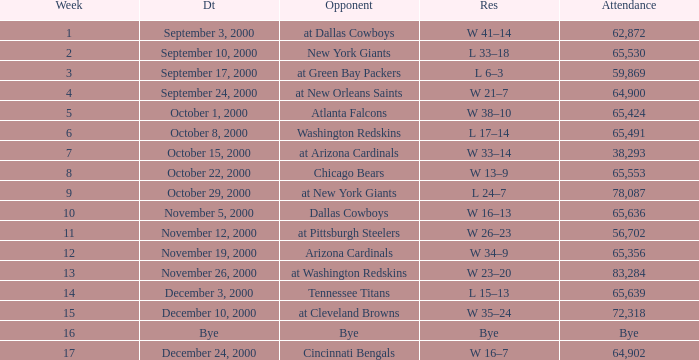What was the attendance when the Cincinnati Bengals were the opponents? 64902.0. 